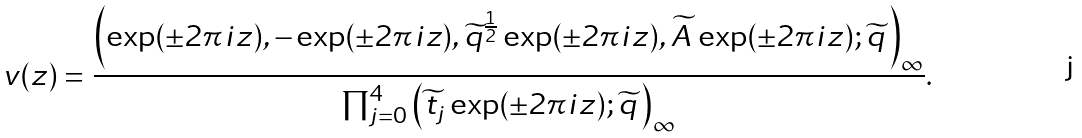<formula> <loc_0><loc_0><loc_500><loc_500>v ( z ) = \frac { \left ( \exp ( \pm 2 \pi i z ) , - \exp ( \pm 2 \pi i z ) , \widetilde { q } ^ { \frac { 1 } { 2 } } \exp ( \pm 2 \pi i z ) , \widetilde { A } \, \exp ( \pm 2 \pi i z ) ; \widetilde { q } \, \right ) _ { \infty } } { \prod _ { j = 0 } ^ { 4 } \left ( \widetilde { t } _ { j } \exp ( \pm 2 \pi i z ) ; \widetilde { q } \, \right ) _ { \infty } } .</formula> 